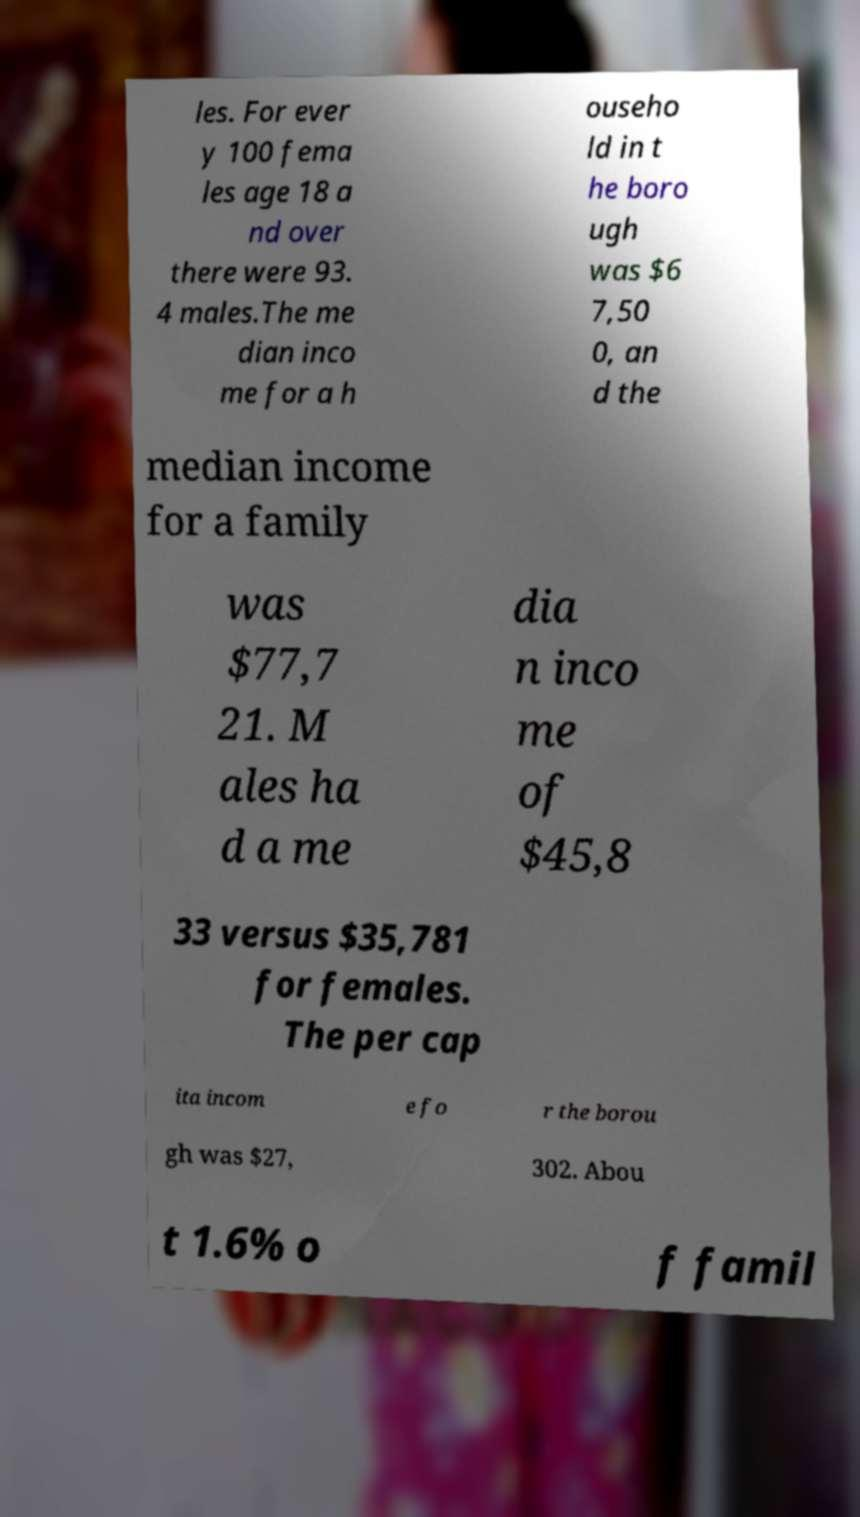Can you accurately transcribe the text from the provided image for me? les. For ever y 100 fema les age 18 a nd over there were 93. 4 males.The me dian inco me for a h ouseho ld in t he boro ugh was $6 7,50 0, an d the median income for a family was $77,7 21. M ales ha d a me dia n inco me of $45,8 33 versus $35,781 for females. The per cap ita incom e fo r the borou gh was $27, 302. Abou t 1.6% o f famil 